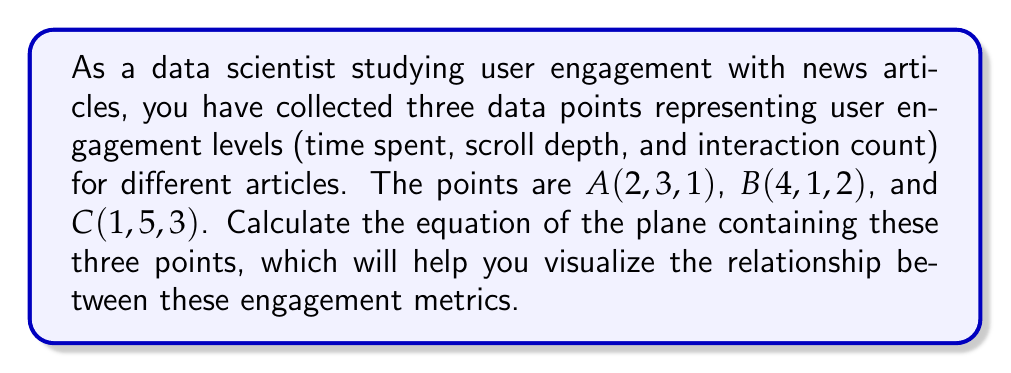Teach me how to tackle this problem. To find the equation of a plane containing three points, we can follow these steps:

1) First, we need to find two vectors on the plane. We can do this by subtracting the coordinates of two points from the third:

   $\vec{AB} = B - A = (4-2, 1-3, 2-1) = (2, -2, 1)$
   $\vec{AC} = C - A = (1-2, 5-3, 3-1) = (-1, 2, 2)$

2) The normal vector to the plane will be the cross product of these two vectors:

   $\vec{n} = \vec{AB} \times \vec{AC} = \begin{vmatrix} 
   i & j & k \\
   2 & -2 & 1 \\
   -1 & 2 & 2
   \end{vmatrix}$

   $= ((-2)(2) - (1)(2))i - ((2)(2) - (1)(-1))j + ((2)(2) - (-2)(-1))k$
   
   $= (-4 - 2)i - (4 + 1)j + (4 - 2)k$
   
   $= -6i - 5j + 2k$

3) The general equation of a plane is $ax + by + cz + d = 0$, where $(a, b, c)$ is the normal vector.

4) Substituting our normal vector and the coordinates of point A:

   $-6x - 5y + 2z + d = 0$
   $-6(2) - 5(3) + 2(1) + d = 0$
   $-12 - 15 + 2 + d = 0$
   $d = 25$

5) Therefore, the equation of the plane is:

   $-6x - 5y + 2z + 25 = 0$

We can simplify this by dividing everything by -1:

   $6x + 5y - 2z = 25$
Answer: $6x + 5y - 2z = 25$ 